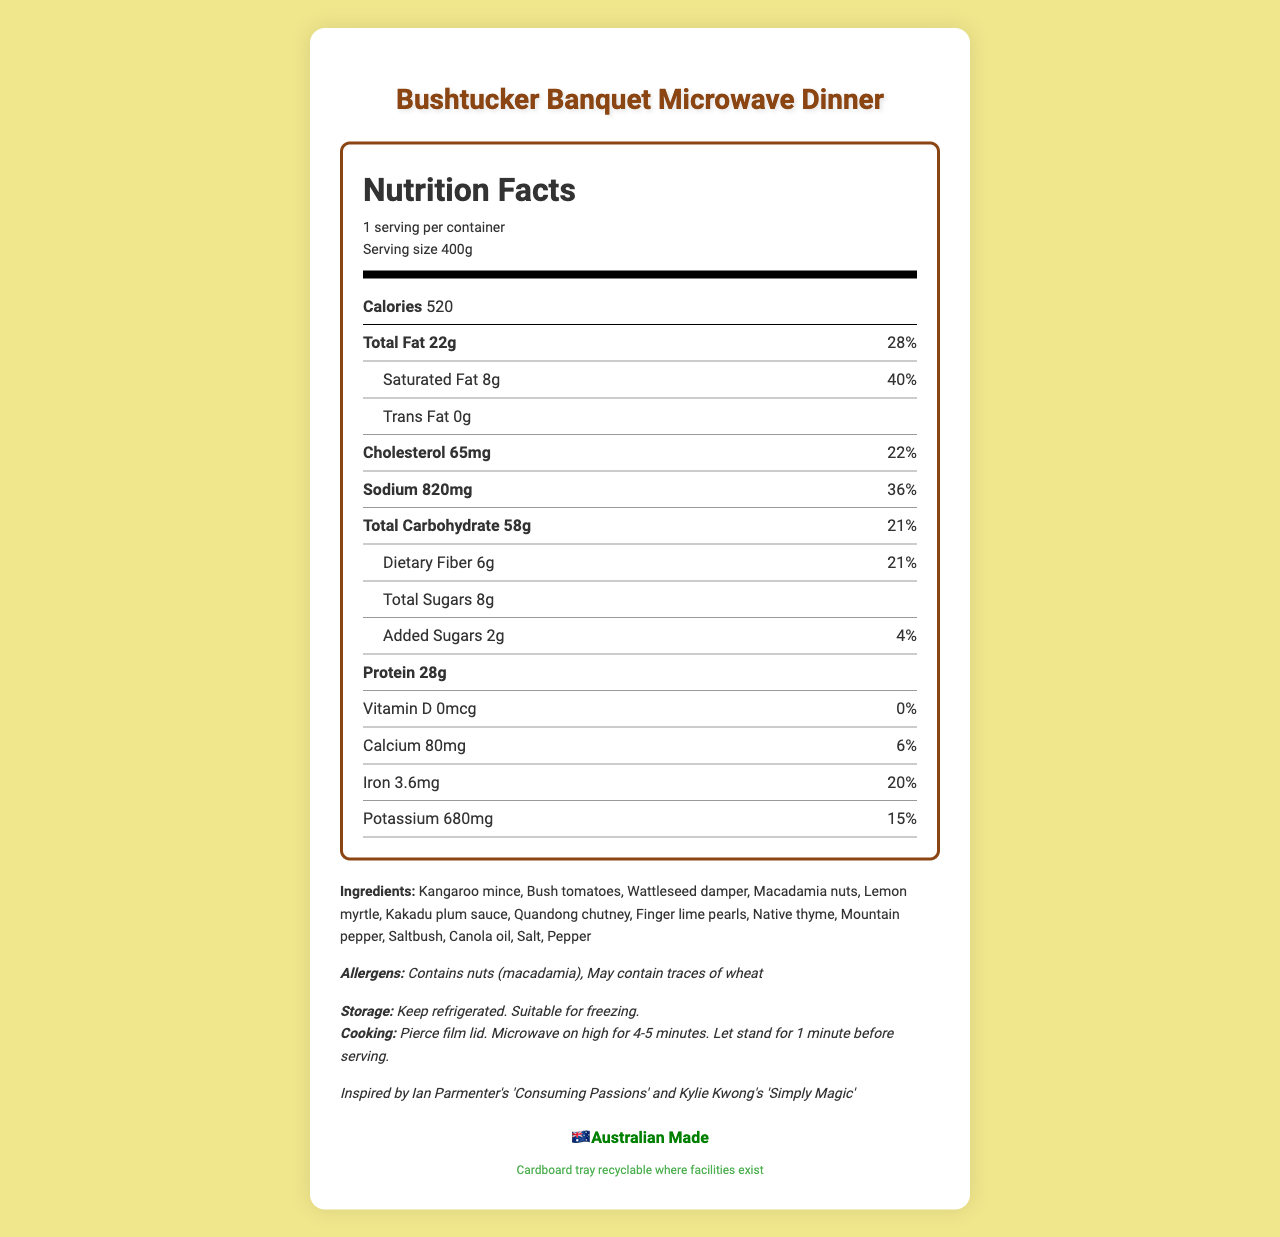what is the serving size of the Bushtucker Banquet Microwave Dinner? According to the nutrition label, the serving size is listed as 400g.
Answer: 400g how many calories does one serving of the Bushtucker Banquet Microwave Dinner contain? The nutrition label specifies that one serving contains 520 calories.
Answer: 520 what are the ingredients of the Bushtucker Banquet Microwave Dinner? The list of ingredients is provided under the 'Ingredients' section in the document.
Answer: Kangaroo mince, Bush tomatoes, Wattleseed damper, Macadamia nuts, Lemon myrtle, Kakadu plum sauce, Quandong chutney, Finger lime pearls, Native thyme, Mountain pepper, Saltbush, Canola oil, Salt, Pepper what is the amount of saturated fat in one serving, and its percentage of the daily value? The nutrition label states that the saturated fat content per serving is 8g, which is 40% of the daily value.
Answer: 8g, 40% is the packaging of the Bushtucker Banquet Microwave Dinner recyclable? There is a text at the bottom of the document indicating that the packaging is recyclable where facilities exist.
Answer: Yes what is the cooking instruction for this microwave dinner? The cooking instructions are listed in the document, which states to pierce the film lid, microwave on high for 4-5 minutes, and let stand for 1 minute.
Answer: Pierce film lid. Microwave on high for 4-5 minutes. Let stand for 1 minute before serving. which of the following nutrients is present in the highest amount in the Bushtucker Banquet Microwave Dinner? A. Cholesterol B. Protein C. Dietary Fiber D. Sodium The amount of protein is 28g, which is higher compared to cholesterol (65mg), dietary fiber (6g), and sodium (820mg).
Answer: B what is the daily value percentage for dietary fiber in one serving of this meal? A. 15% B. 18% C. 21% D. 28% The daily value percentage for dietary fiber is listed as 21% on the nutrition label.
Answer: C is this product inspired by any Australian cooking shows? The document mentions that the product was inspired by Ian Parmenter's 'Consuming Passions' and Kylie Kwong's 'Simply Magic'.
Answer: Yes is there any trans fat in the Bushtucker Banquet Microwave Dinner? The nutrition label explicitly states that there is 0g of trans fat.
Answer: No summarize the main details of the document. The document provides a comprehensive nutritional analysis of the microwave dinner, lists its ingredients, allergens, and cooking/storage instructions, and mentions its inspiration from Australian cooking shows. It also includes information on packaging recyclability and the Australian Made logo.
Answer: This document is a nutrition facts label for the "Bushtucker Banquet Microwave Dinner." It provides detailed nutritional information per serving, such as 520 calories, 28g of protein, 22g of total fat, 8g of saturated fat, and other nutrients. It lists ingredients such as kangaroo mince and bush tomatoes and includes cooking and storage instructions. The label also highlights that the meal is inspired by classic Australian cooking shows and confirms its recyclable packaging. An Australian Made logo is present. Allergens include macadamia nuts and possible traces of wheat. where is the sodium value higher: in a serving of Bushtucker Banquet Microwave Dinner or a typical 2000mg per day intake? The document only provides the sodium content for one serving (820mg) of the product but does not compare it directly with other values. Further information would be needed to make this comparison.
Answer: Not enough information 